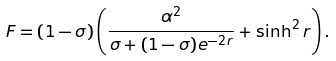Convert formula to latex. <formula><loc_0><loc_0><loc_500><loc_500>F = ( 1 - \sigma ) \left ( \frac { \alpha ^ { 2 } } { \sigma + ( 1 - \sigma ) e ^ { - 2 r } } + \sinh ^ { 2 } r \right ) .</formula> 